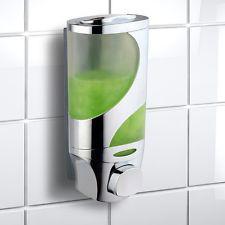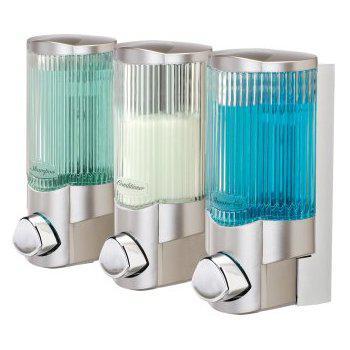The first image is the image on the left, the second image is the image on the right. For the images shown, is this caption "there is exactly one dispensing button in one of the images" true? Answer yes or no. Yes. The first image is the image on the left, the second image is the image on the right. For the images shown, is this caption "There is at least one single soap dispenser in each image." true? Answer yes or no. Yes. 